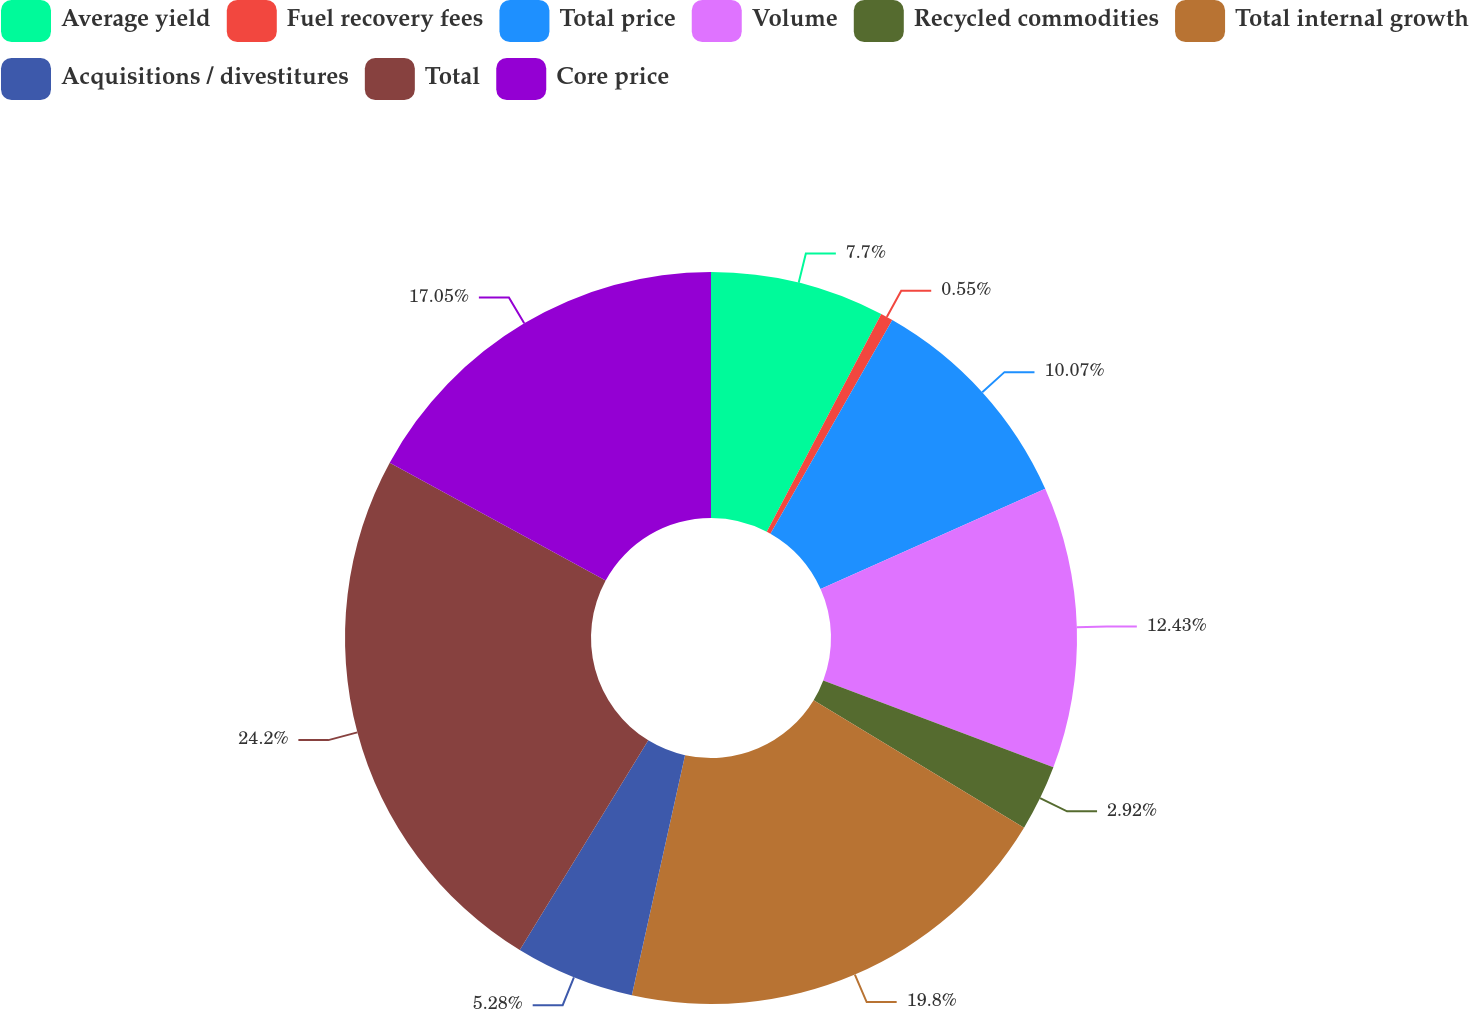Convert chart to OTSL. <chart><loc_0><loc_0><loc_500><loc_500><pie_chart><fcel>Average yield<fcel>Fuel recovery fees<fcel>Total price<fcel>Volume<fcel>Recycled commodities<fcel>Total internal growth<fcel>Acquisitions / divestitures<fcel>Total<fcel>Core price<nl><fcel>7.7%<fcel>0.55%<fcel>10.07%<fcel>12.43%<fcel>2.92%<fcel>19.8%<fcel>5.28%<fcel>24.2%<fcel>17.05%<nl></chart> 